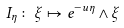<formula> <loc_0><loc_0><loc_500><loc_500>I _ { \eta } \colon \xi \mapsto e ^ { - u \eta } \wedge \xi</formula> 